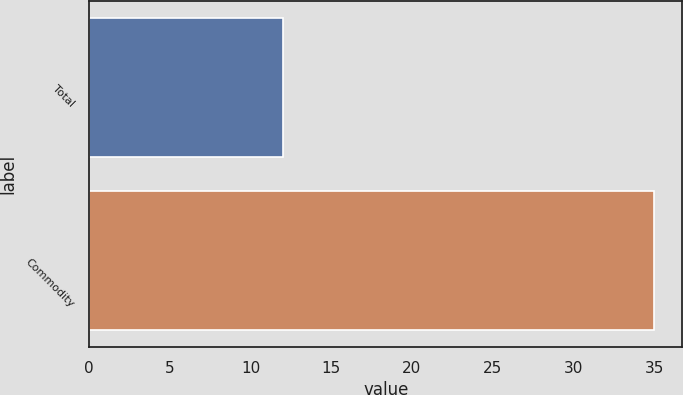Convert chart to OTSL. <chart><loc_0><loc_0><loc_500><loc_500><bar_chart><fcel>Total<fcel>Commodity<nl><fcel>12<fcel>35<nl></chart> 